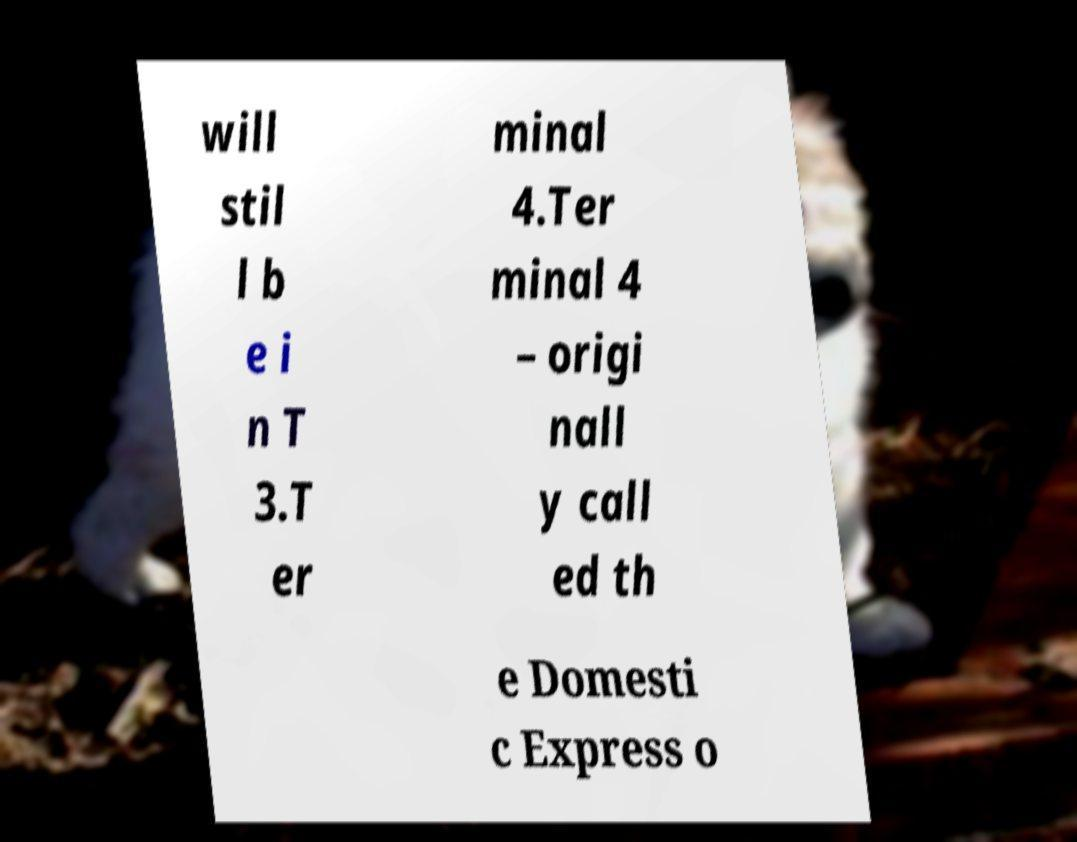Can you accurately transcribe the text from the provided image for me? will stil l b e i n T 3.T er minal 4.Ter minal 4 – origi nall y call ed th e Domesti c Express o 